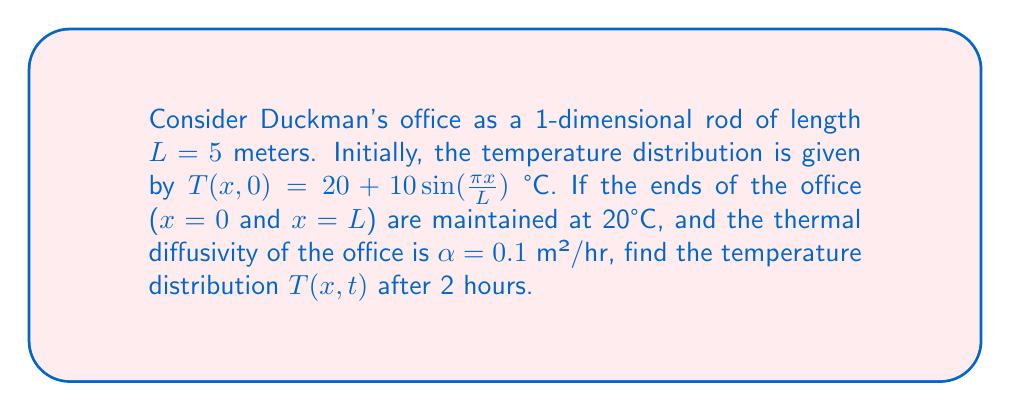Teach me how to tackle this problem. To solve this problem, we'll use the heat equation in one dimension:

1) The heat equation: $\frac{\partial T}{\partial t} = \alpha \frac{\partial^2 T}{\partial x^2}$

2) Boundary conditions: $T(0,t) = T(L,t) = 20$ °C

3) Initial condition: $T(x,0) = 20 + 10\sin(\frac{\pi x}{L})$ °C

4) We can use separation of variables to solve this equation. The general solution has the form:

   $T(x,t) = 20 + \sum_{n=1}^{\infty} B_n \sin(\frac{n\pi x}{L}) e^{-\alpha(\frac{n\pi}{L})^2t}$

5) The initial condition matches the n = 1 term of this series, so we only need this term:

   $T(x,t) = 20 + 10\sin(\frac{\pi x}{L}) e^{-\alpha(\frac{\pi}{L})^2t}$

6) Substituting the given values:
   L = 5 m
   α = 0.1 m²/hr
   t = 2 hr

7) $T(x,2) = 20 + 10\sin(\frac{\pi x}{5}) e^{-0.1(\frac{\pi}{5})^2 \cdot 2}$

8) Simplify the exponent: $e^{-0.1(\frac{\pi}{5})^2 \cdot 2} \approx 0.7165$

9) Final temperature distribution:

   $T(x,2) = 20 + 7.165\sin(\frac{\pi x}{5})$ °C
Answer: $T(x,2) = 20 + 7.165\sin(\frac{\pi x}{5})$ °C 